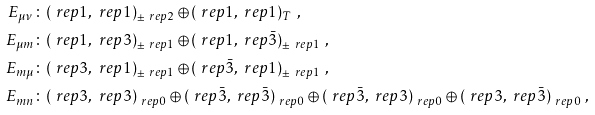Convert formula to latex. <formula><loc_0><loc_0><loc_500><loc_500>E _ { \mu \nu } & \colon ( \ r e p { 1 } , \ r e p { 1 } ) _ { \pm \ r e p { 2 } } \oplus ( \ r e p { 1 } , \ r e p { 1 } ) _ { T } \ , \\ E _ { \mu m } & \colon ( \ r e p { 1 } , \ r e p { 3 } ) _ { \pm \ r e p { 1 } } \oplus ( \ r e p { 1 } , \ r e p { \bar { 3 } } ) _ { \pm \ r e p { 1 } } \ , \\ E _ { m \mu } & \colon ( \ r e p { 3 } , \ r e p { 1 } ) _ { \pm \ r e p { 1 } } \oplus ( \ r e p { \bar { 3 } } , \ r e p { 1 } ) _ { \pm \ r e p { 1 } } \ , \\ E _ { m n } & \colon ( \ r e p { 3 } , \ r e p { 3 } ) _ { \ r e p { 0 } } \oplus ( \ r e p { \bar { 3 } } , \ r e p { \bar { 3 } } ) _ { \ r e p { 0 } } \oplus ( \ r e p { \bar { 3 } } , \ r e p { 3 } ) _ { \ r e p { 0 } } \oplus ( \ r e p { 3 } , \ r e p { \bar { 3 } } ) _ { \ r e p { 0 } } \ ,</formula> 